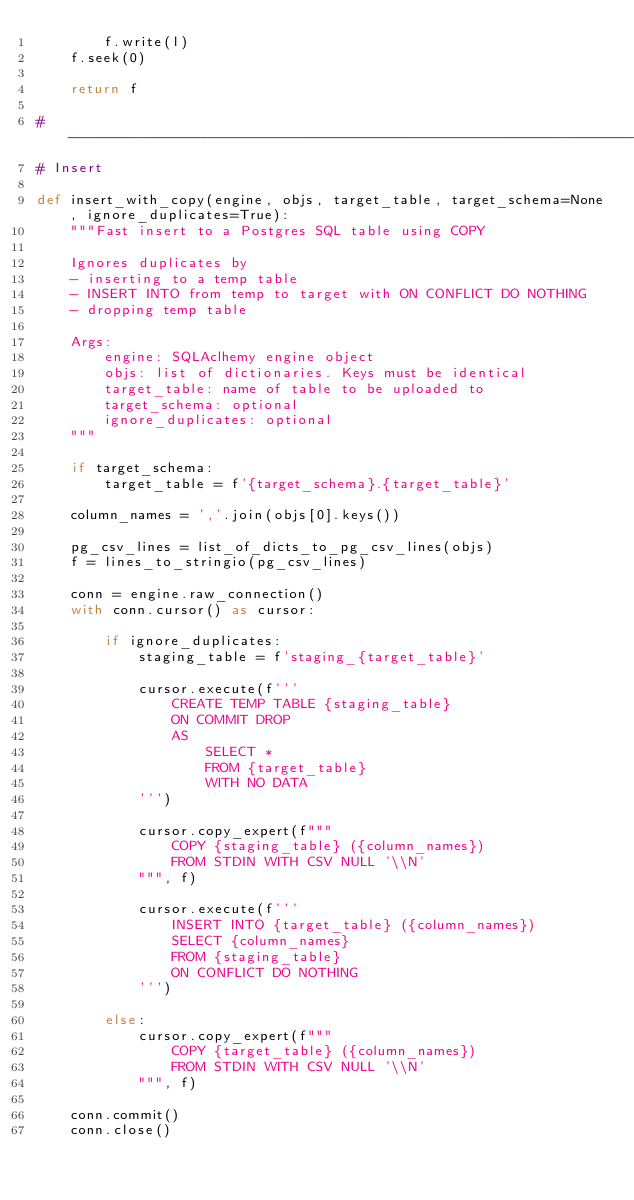<code> <loc_0><loc_0><loc_500><loc_500><_Python_>        f.write(l)
    f.seek(0)

    return f

# ------------------------------------------------------------------------------
# Insert

def insert_with_copy(engine, objs, target_table, target_schema=None, ignore_duplicates=True):
    """Fast insert to a Postgres SQL table using COPY

    Ignores duplicates by
    - inserting to a temp table
    - INSERT INTO from temp to target with ON CONFLICT DO NOTHING
    - dropping temp table

    Args:
        engine: SQLAclhemy engine object
        objs: list of dictionaries. Keys must be identical
        target_table: name of table to be uploaded to
        target_schema: optional
        ignore_duplicates: optional
    """

    if target_schema:
        target_table = f'{target_schema}.{target_table}'

    column_names = ','.join(objs[0].keys())

    pg_csv_lines = list_of_dicts_to_pg_csv_lines(objs)
    f = lines_to_stringio(pg_csv_lines)

    conn = engine.raw_connection()
    with conn.cursor() as cursor:

        if ignore_duplicates:
            staging_table = f'staging_{target_table}'

            cursor.execute(f'''
                CREATE TEMP TABLE {staging_table}
                ON COMMIT DROP
                AS
                    SELECT *
                    FROM {target_table}
                    WITH NO DATA
            ''')

            cursor.copy_expert(f"""
                COPY {staging_table} ({column_names})
                FROM STDIN WITH CSV NULL '\\N'
            """, f)

            cursor.execute(f'''
                INSERT INTO {target_table} ({column_names})
                SELECT {column_names}
                FROM {staging_table}
                ON CONFLICT DO NOTHING
            ''')

        else:
            cursor.copy_expert(f"""
                COPY {target_table} ({column_names})
                FROM STDIN WITH CSV NULL '\\N'
            """, f)

    conn.commit()
    conn.close()
</code> 